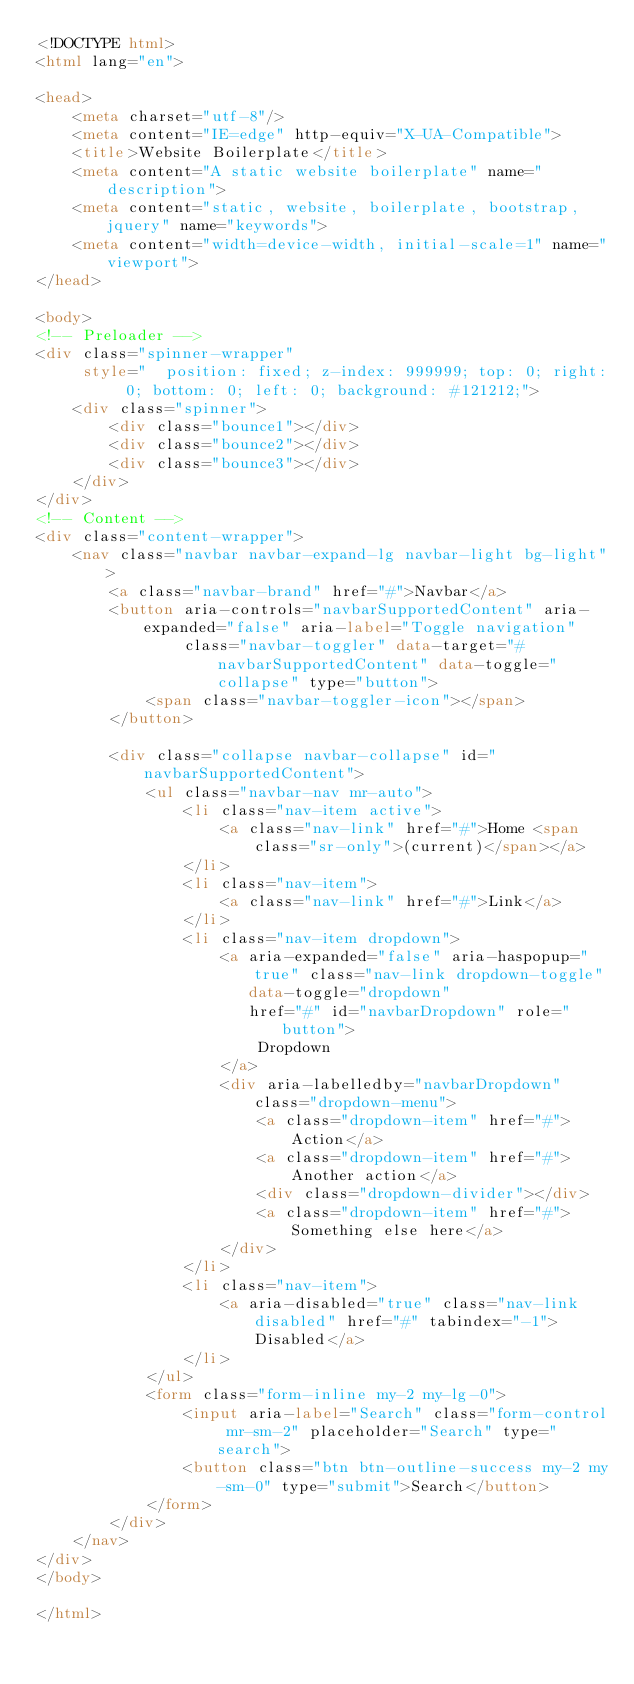<code> <loc_0><loc_0><loc_500><loc_500><_HTML_><!DOCTYPE html>
<html lang="en">

<head>
    <meta charset="utf-8"/>
    <meta content="IE=edge" http-equiv="X-UA-Compatible">
    <title>Website Boilerplate</title>
    <meta content="A static website boilerplate" name="description">
    <meta content="static, website, boilerplate, bootstrap, jquery" name="keywords">
    <meta content="width=device-width, initial-scale=1" name="viewport">
</head>

<body>
<!-- Preloader -->
<div class="spinner-wrapper"
     style="  position: fixed; z-index: 999999; top: 0; right: 0; bottom: 0; left: 0; background: #121212;">
    <div class="spinner">
        <div class="bounce1"></div>
        <div class="bounce2"></div>
        <div class="bounce3"></div>
    </div>
</div>
<!-- Content -->
<div class="content-wrapper">
    <nav class="navbar navbar-expand-lg navbar-light bg-light">
        <a class="navbar-brand" href="#">Navbar</a>
        <button aria-controls="navbarSupportedContent" aria-expanded="false" aria-label="Toggle navigation"
                class="navbar-toggler" data-target="#navbarSupportedContent" data-toggle="collapse" type="button">
            <span class="navbar-toggler-icon"></span>
        </button>

        <div class="collapse navbar-collapse" id="navbarSupportedContent">
            <ul class="navbar-nav mr-auto">
                <li class="nav-item active">
                    <a class="nav-link" href="#">Home <span class="sr-only">(current)</span></a>
                </li>
                <li class="nav-item">
                    <a class="nav-link" href="#">Link</a>
                </li>
                <li class="nav-item dropdown">
                    <a aria-expanded="false" aria-haspopup="true" class="nav-link dropdown-toggle"
                       data-toggle="dropdown"
                       href="#" id="navbarDropdown" role="button">
                        Dropdown
                    </a>
                    <div aria-labelledby="navbarDropdown" class="dropdown-menu">
                        <a class="dropdown-item" href="#">Action</a>
                        <a class="dropdown-item" href="#">Another action</a>
                        <div class="dropdown-divider"></div>
                        <a class="dropdown-item" href="#">Something else here</a>
                    </div>
                </li>
                <li class="nav-item">
                    <a aria-disabled="true" class="nav-link disabled" href="#" tabindex="-1">Disabled</a>
                </li>
            </ul>
            <form class="form-inline my-2 my-lg-0">
                <input aria-label="Search" class="form-control mr-sm-2" placeholder="Search" type="search">
                <button class="btn btn-outline-success my-2 my-sm-0" type="submit">Search</button>
            </form>
        </div>
    </nav>
</div>
</body>

</html>
</code> 